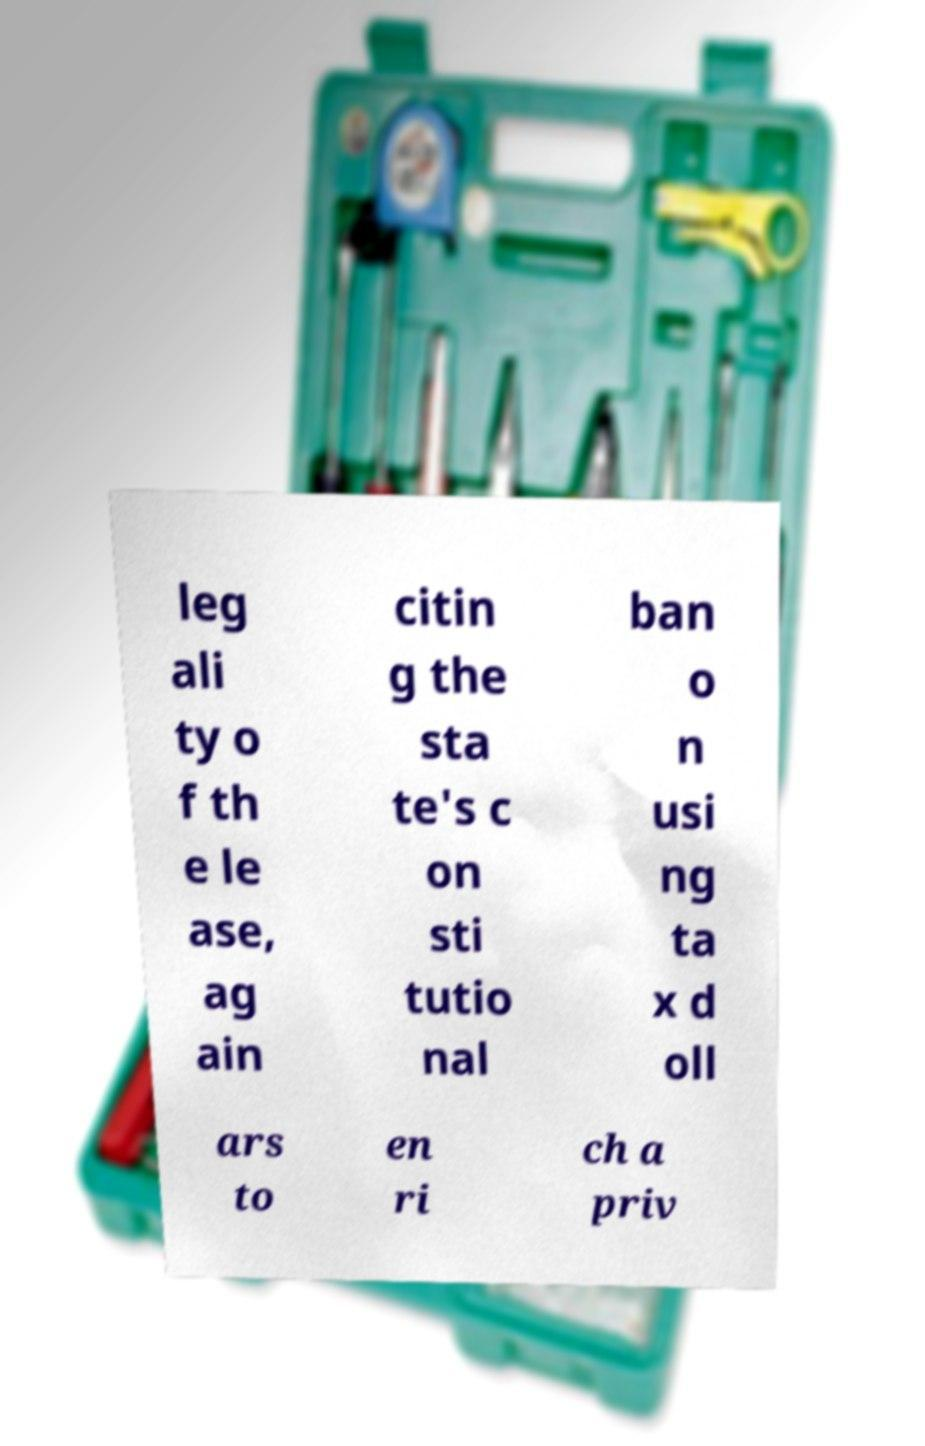Please read and relay the text visible in this image. What does it say? leg ali ty o f th e le ase, ag ain citin g the sta te's c on sti tutio nal ban o n usi ng ta x d oll ars to en ri ch a priv 